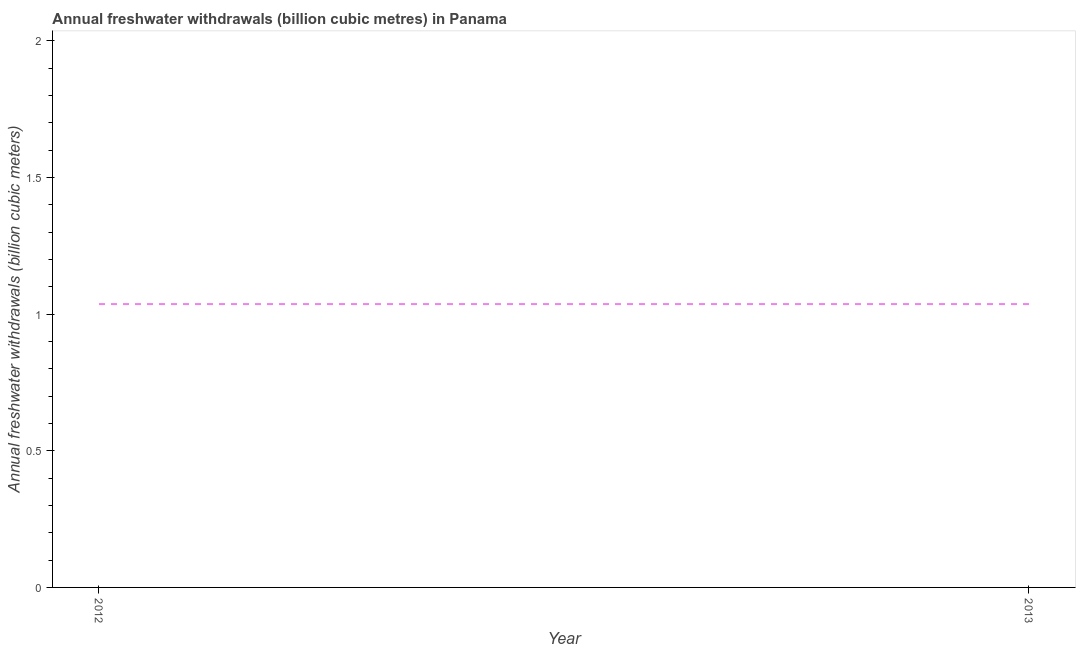What is the annual freshwater withdrawals in 2013?
Your response must be concise. 1.04. Across all years, what is the maximum annual freshwater withdrawals?
Provide a succinct answer. 1.04. Across all years, what is the minimum annual freshwater withdrawals?
Ensure brevity in your answer.  1.04. What is the sum of the annual freshwater withdrawals?
Ensure brevity in your answer.  2.07. What is the median annual freshwater withdrawals?
Provide a short and direct response. 1.04. Do a majority of the years between 2013 and 2012 (inclusive) have annual freshwater withdrawals greater than 1 billion cubic meters?
Keep it short and to the point. No. In how many years, is the annual freshwater withdrawals greater than the average annual freshwater withdrawals taken over all years?
Offer a very short reply. 0. Does the annual freshwater withdrawals monotonically increase over the years?
Keep it short and to the point. No. How many lines are there?
Offer a very short reply. 1. How many years are there in the graph?
Your answer should be compact. 2. Are the values on the major ticks of Y-axis written in scientific E-notation?
Ensure brevity in your answer.  No. What is the title of the graph?
Your answer should be compact. Annual freshwater withdrawals (billion cubic metres) in Panama. What is the label or title of the X-axis?
Give a very brief answer. Year. What is the label or title of the Y-axis?
Provide a short and direct response. Annual freshwater withdrawals (billion cubic meters). What is the Annual freshwater withdrawals (billion cubic meters) in 2012?
Your response must be concise. 1.04. What is the difference between the Annual freshwater withdrawals (billion cubic meters) in 2012 and 2013?
Provide a succinct answer. 0. 